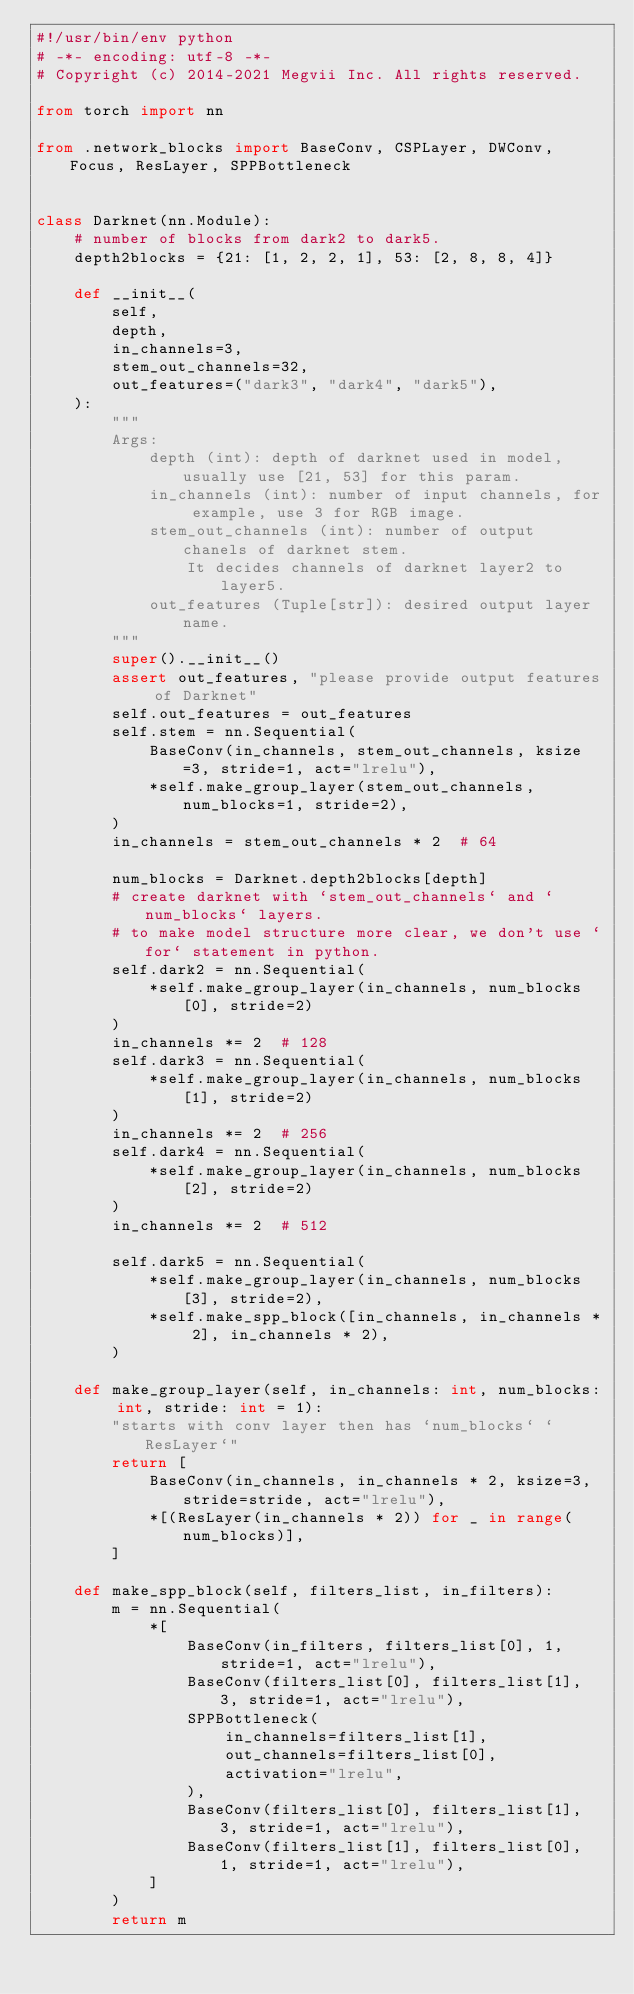Convert code to text. <code><loc_0><loc_0><loc_500><loc_500><_Python_>#!/usr/bin/env python
# -*- encoding: utf-8 -*-
# Copyright (c) 2014-2021 Megvii Inc. All rights reserved.

from torch import nn

from .network_blocks import BaseConv, CSPLayer, DWConv, Focus, ResLayer, SPPBottleneck


class Darknet(nn.Module):
    # number of blocks from dark2 to dark5.
    depth2blocks = {21: [1, 2, 2, 1], 53: [2, 8, 8, 4]}

    def __init__(
        self,
        depth,
        in_channels=3,
        stem_out_channels=32,
        out_features=("dark3", "dark4", "dark5"),
    ):
        """
        Args:
            depth (int): depth of darknet used in model, usually use [21, 53] for this param.
            in_channels (int): number of input channels, for example, use 3 for RGB image.
            stem_out_channels (int): number of output chanels of darknet stem.
                It decides channels of darknet layer2 to layer5.
            out_features (Tuple[str]): desired output layer name.
        """
        super().__init__()
        assert out_features, "please provide output features of Darknet"
        self.out_features = out_features
        self.stem = nn.Sequential(
            BaseConv(in_channels, stem_out_channels, ksize=3, stride=1, act="lrelu"),
            *self.make_group_layer(stem_out_channels, num_blocks=1, stride=2),
        )
        in_channels = stem_out_channels * 2  # 64

        num_blocks = Darknet.depth2blocks[depth]
        # create darknet with `stem_out_channels` and `num_blocks` layers.
        # to make model structure more clear, we don't use `for` statement in python.
        self.dark2 = nn.Sequential(
            *self.make_group_layer(in_channels, num_blocks[0], stride=2)
        )
        in_channels *= 2  # 128
        self.dark3 = nn.Sequential(
            *self.make_group_layer(in_channels, num_blocks[1], stride=2)
        )
        in_channels *= 2  # 256
        self.dark4 = nn.Sequential(
            *self.make_group_layer(in_channels, num_blocks[2], stride=2)
        )
        in_channels *= 2  # 512

        self.dark5 = nn.Sequential(
            *self.make_group_layer(in_channels, num_blocks[3], stride=2),
            *self.make_spp_block([in_channels, in_channels * 2], in_channels * 2),
        )

    def make_group_layer(self, in_channels: int, num_blocks: int, stride: int = 1):
        "starts with conv layer then has `num_blocks` `ResLayer`"
        return [
            BaseConv(in_channels, in_channels * 2, ksize=3, stride=stride, act="lrelu"),
            *[(ResLayer(in_channels * 2)) for _ in range(num_blocks)],
        ]

    def make_spp_block(self, filters_list, in_filters):
        m = nn.Sequential(
            *[
                BaseConv(in_filters, filters_list[0], 1, stride=1, act="lrelu"),
                BaseConv(filters_list[0], filters_list[1], 3, stride=1, act="lrelu"),
                SPPBottleneck(
                    in_channels=filters_list[1],
                    out_channels=filters_list[0],
                    activation="lrelu",
                ),
                BaseConv(filters_list[0], filters_list[1], 3, stride=1, act="lrelu"),
                BaseConv(filters_list[1], filters_list[0], 1, stride=1, act="lrelu"),
            ]
        )
        return m
</code> 